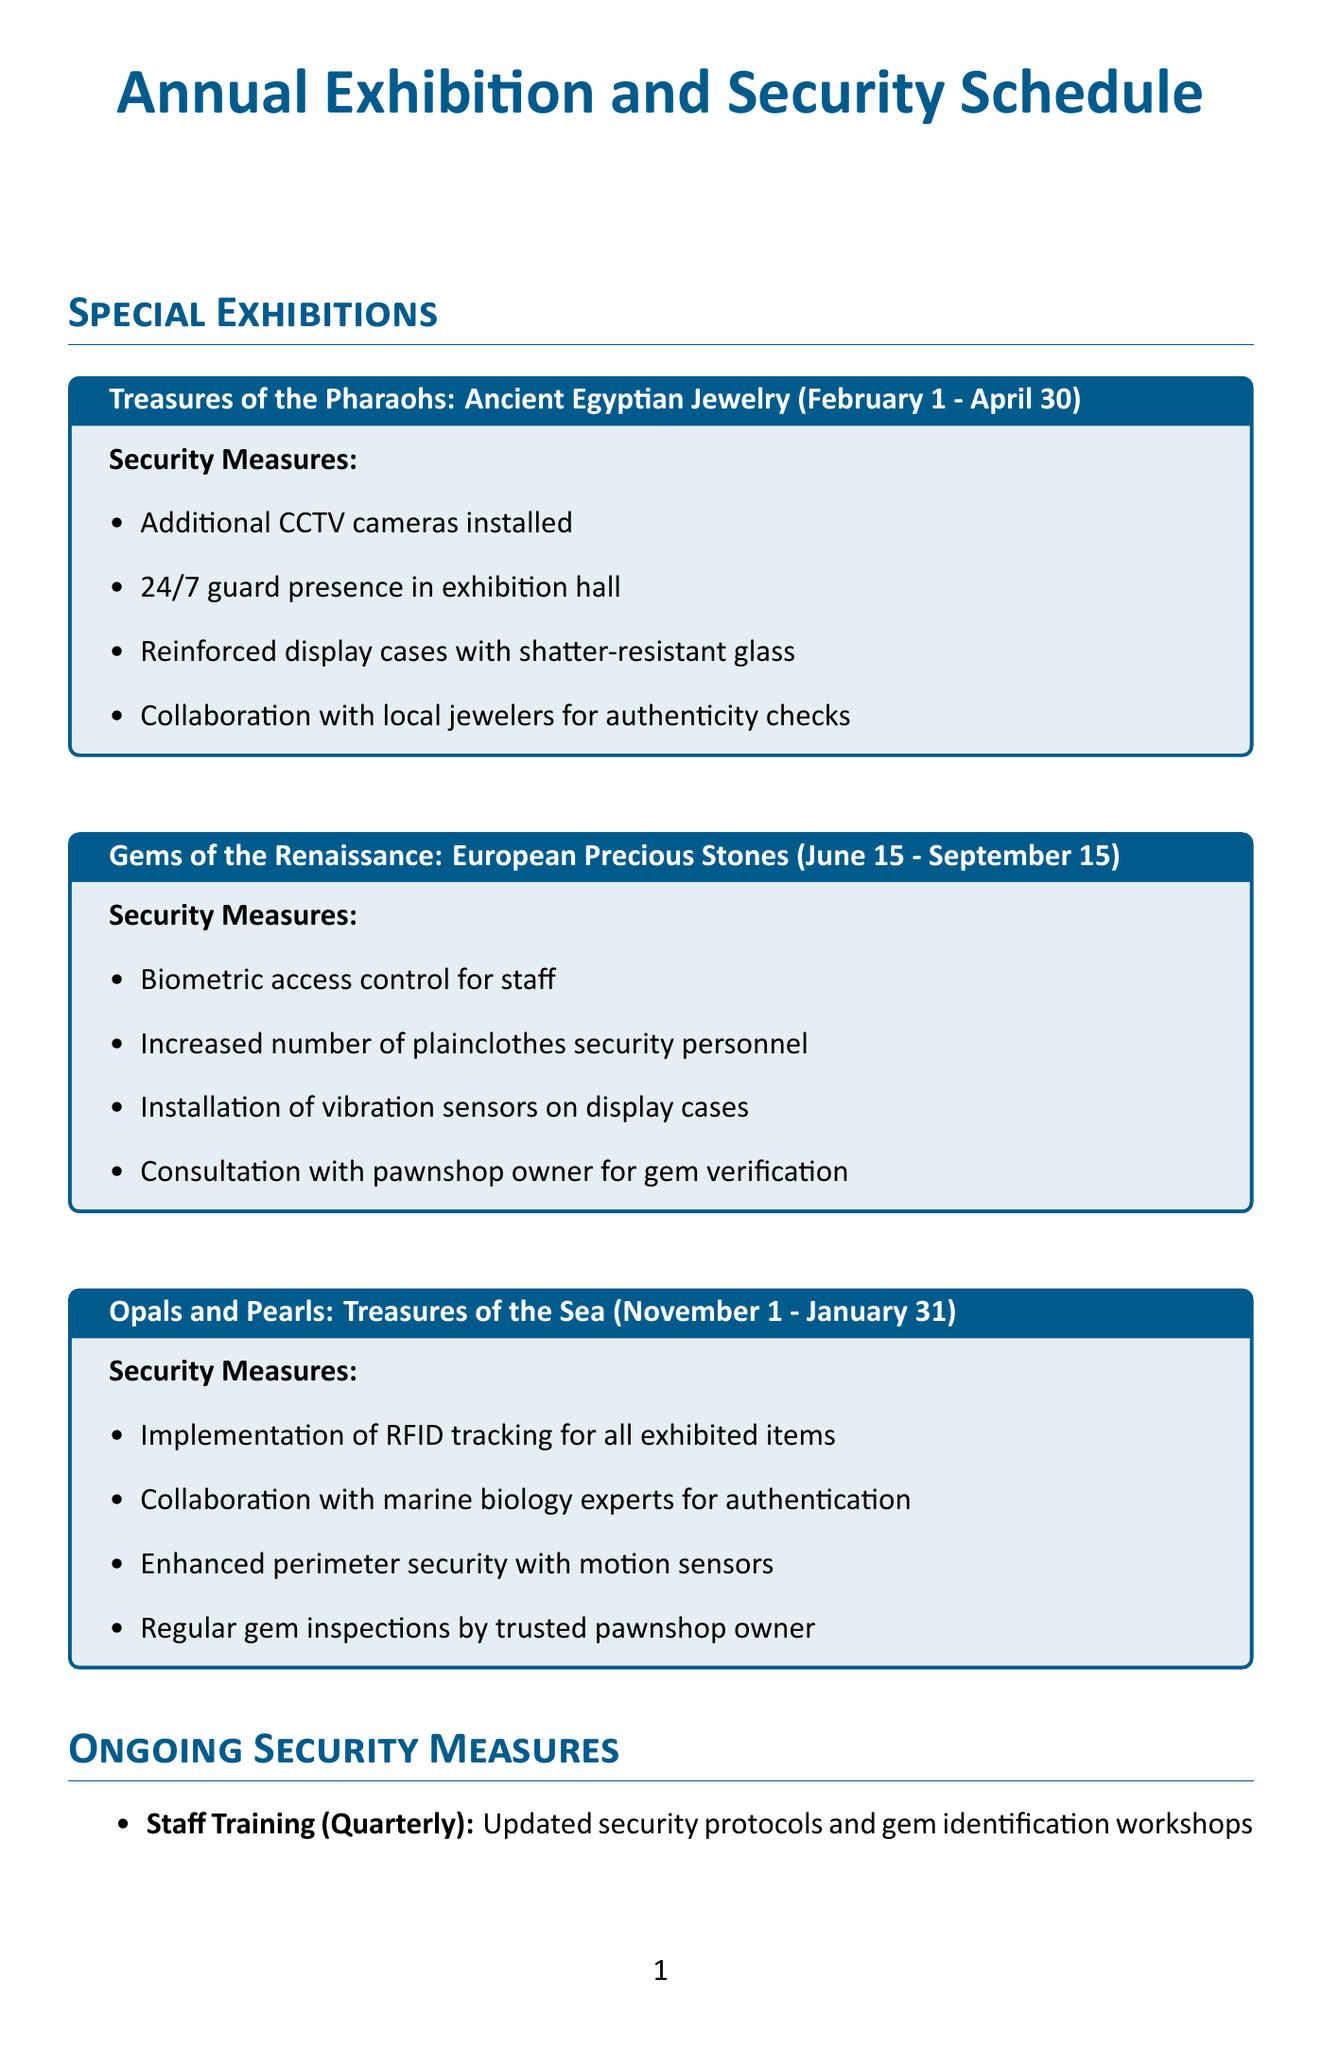What is the name of the exhibition from February 1 to April 30? The exhibition scheduled for this date range is "Treasures of the Pharaohs: Ancient Egyptian Jewelry."
Answer: Treasures of the Pharaohs: Ancient Egyptian Jewelry How long does the "Gems of the Renaissance" exhibition last? The "Gems of the Renaissance" exhibition runs from June 15 to September 15, which is a total of 3 months.
Answer: 3 months What security measure is implemented for the exhibition of Opals and Pearls? The security measures include RFID tracking for all exhibited items during the Opals and Pearls exhibition.
Answer: RFID tracking What is the date of the International Museum Day? The International Museum Day is held on May 18.
Answer: May 18 How often are staff training sessions conducted? Staff training sessions take place quarterly, as specified in the ongoing security measures.
Answer: Quarterly Which organization collaborates for annual staff training? The collaboration for annual staff training is with the Gemological Institute of America.
Answer: Gemological Institute of America What security measure involves local law enforcement during special events? The collaboration with local law enforcement is for crowd management during events like International Museum Day.
Answer: Crowd management How frequently are external audits conducted? External audits are performed bi-annually according to the ongoing security measures.
Answer: Bi-annually Who is the expert contact for the local pawnshop? The contact person for the local pawnshop is James Miller.
Answer: James Miller 